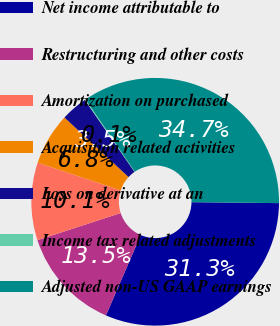Convert chart to OTSL. <chart><loc_0><loc_0><loc_500><loc_500><pie_chart><fcel>Net income attributable to<fcel>Restructuring and other costs<fcel>Amortization on purchased<fcel>Acquisition related activities<fcel>Loss on derivative at an<fcel>Income tax related adjustments<fcel>Adjusted non-US GAAP earnings<nl><fcel>31.34%<fcel>13.47%<fcel>10.13%<fcel>6.8%<fcel>3.46%<fcel>0.13%<fcel>34.67%<nl></chart> 